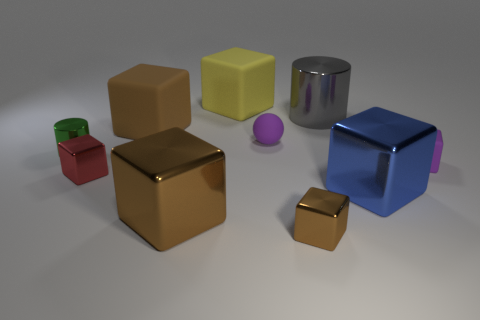The small matte block has what color?
Give a very brief answer. Purple. The purple rubber object on the left side of the shiny cylinder right of the large brown block that is behind the tiny green shiny thing is what shape?
Offer a very short reply. Sphere. What number of other objects are the same color as the sphere?
Offer a very short reply. 1. Are there more matte blocks that are behind the tiny brown shiny block than small rubber balls that are behind the big blue metal block?
Give a very brief answer. Yes. Are there any brown blocks in front of the green cylinder?
Ensure brevity in your answer.  Yes. What material is the brown thing that is in front of the sphere and left of the small brown object?
Offer a terse response. Metal. There is another object that is the same shape as the green object; what is its color?
Your answer should be compact. Gray. There is a big cube that is in front of the blue shiny thing; is there a small matte sphere to the left of it?
Your answer should be very brief. No. What size is the purple ball?
Your response must be concise. Small. What is the shape of the big object that is behind the tiny matte sphere and to the right of the ball?
Your answer should be compact. Cylinder. 